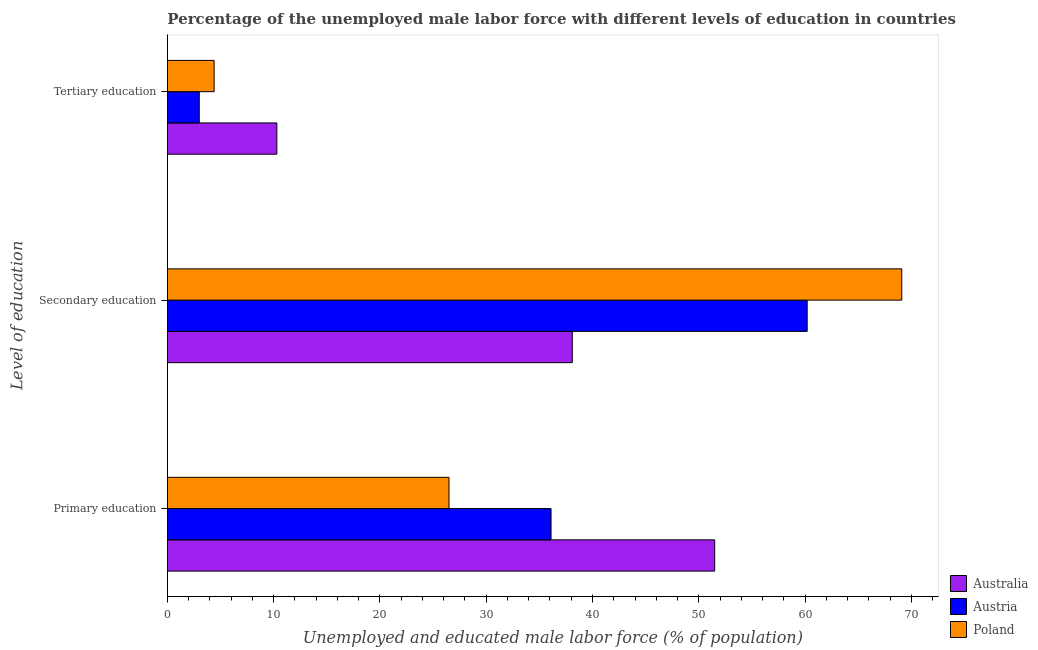How many groups of bars are there?
Provide a succinct answer. 3. Are the number of bars per tick equal to the number of legend labels?
Your answer should be very brief. Yes. How many bars are there on the 3rd tick from the top?
Provide a short and direct response. 3. How many bars are there on the 1st tick from the bottom?
Your response must be concise. 3. What is the label of the 1st group of bars from the top?
Offer a very short reply. Tertiary education. Across all countries, what is the maximum percentage of male labor force who received tertiary education?
Provide a short and direct response. 10.3. Across all countries, what is the minimum percentage of male labor force who received tertiary education?
Provide a succinct answer. 3. What is the total percentage of male labor force who received primary education in the graph?
Your response must be concise. 114.1. What is the difference between the percentage of male labor force who received secondary education in Australia and that in Poland?
Offer a very short reply. -31. What is the difference between the percentage of male labor force who received secondary education in Austria and the percentage of male labor force who received primary education in Poland?
Your answer should be very brief. 33.7. What is the average percentage of male labor force who received secondary education per country?
Your response must be concise. 55.8. What is the difference between the percentage of male labor force who received primary education and percentage of male labor force who received secondary education in Poland?
Give a very brief answer. -42.6. In how many countries, is the percentage of male labor force who received tertiary education greater than 66 %?
Offer a very short reply. 0. What is the ratio of the percentage of male labor force who received tertiary education in Austria to that in Australia?
Give a very brief answer. 0.29. Is the percentage of male labor force who received primary education in Australia less than that in Poland?
Your answer should be very brief. No. Is the difference between the percentage of male labor force who received primary education in Australia and Poland greater than the difference between the percentage of male labor force who received tertiary education in Australia and Poland?
Make the answer very short. Yes. What is the difference between the highest and the second highest percentage of male labor force who received secondary education?
Give a very brief answer. 8.9. What is the difference between the highest and the lowest percentage of male labor force who received secondary education?
Ensure brevity in your answer.  31. What does the 3rd bar from the top in Secondary education represents?
Make the answer very short. Australia. Is it the case that in every country, the sum of the percentage of male labor force who received primary education and percentage of male labor force who received secondary education is greater than the percentage of male labor force who received tertiary education?
Give a very brief answer. Yes. Are all the bars in the graph horizontal?
Make the answer very short. Yes. How many countries are there in the graph?
Your answer should be compact. 3. What is the difference between two consecutive major ticks on the X-axis?
Make the answer very short. 10. Are the values on the major ticks of X-axis written in scientific E-notation?
Offer a very short reply. No. How are the legend labels stacked?
Offer a very short reply. Vertical. What is the title of the graph?
Provide a succinct answer. Percentage of the unemployed male labor force with different levels of education in countries. What is the label or title of the X-axis?
Your answer should be compact. Unemployed and educated male labor force (% of population). What is the label or title of the Y-axis?
Offer a terse response. Level of education. What is the Unemployed and educated male labor force (% of population) of Australia in Primary education?
Offer a terse response. 51.5. What is the Unemployed and educated male labor force (% of population) of Austria in Primary education?
Your response must be concise. 36.1. What is the Unemployed and educated male labor force (% of population) in Poland in Primary education?
Make the answer very short. 26.5. What is the Unemployed and educated male labor force (% of population) in Australia in Secondary education?
Your response must be concise. 38.1. What is the Unemployed and educated male labor force (% of population) in Austria in Secondary education?
Make the answer very short. 60.2. What is the Unemployed and educated male labor force (% of population) of Poland in Secondary education?
Your response must be concise. 69.1. What is the Unemployed and educated male labor force (% of population) in Australia in Tertiary education?
Give a very brief answer. 10.3. What is the Unemployed and educated male labor force (% of population) of Austria in Tertiary education?
Your response must be concise. 3. What is the Unemployed and educated male labor force (% of population) in Poland in Tertiary education?
Provide a succinct answer. 4.4. Across all Level of education, what is the maximum Unemployed and educated male labor force (% of population) in Australia?
Give a very brief answer. 51.5. Across all Level of education, what is the maximum Unemployed and educated male labor force (% of population) in Austria?
Your answer should be compact. 60.2. Across all Level of education, what is the maximum Unemployed and educated male labor force (% of population) in Poland?
Offer a terse response. 69.1. Across all Level of education, what is the minimum Unemployed and educated male labor force (% of population) of Australia?
Give a very brief answer. 10.3. Across all Level of education, what is the minimum Unemployed and educated male labor force (% of population) of Poland?
Give a very brief answer. 4.4. What is the total Unemployed and educated male labor force (% of population) of Australia in the graph?
Provide a succinct answer. 99.9. What is the total Unemployed and educated male labor force (% of population) of Austria in the graph?
Give a very brief answer. 99.3. What is the difference between the Unemployed and educated male labor force (% of population) in Australia in Primary education and that in Secondary education?
Make the answer very short. 13.4. What is the difference between the Unemployed and educated male labor force (% of population) of Austria in Primary education and that in Secondary education?
Your answer should be very brief. -24.1. What is the difference between the Unemployed and educated male labor force (% of population) in Poland in Primary education and that in Secondary education?
Provide a succinct answer. -42.6. What is the difference between the Unemployed and educated male labor force (% of population) of Australia in Primary education and that in Tertiary education?
Offer a very short reply. 41.2. What is the difference between the Unemployed and educated male labor force (% of population) in Austria in Primary education and that in Tertiary education?
Keep it short and to the point. 33.1. What is the difference between the Unemployed and educated male labor force (% of population) in Poland in Primary education and that in Tertiary education?
Offer a very short reply. 22.1. What is the difference between the Unemployed and educated male labor force (% of population) of Australia in Secondary education and that in Tertiary education?
Provide a short and direct response. 27.8. What is the difference between the Unemployed and educated male labor force (% of population) of Austria in Secondary education and that in Tertiary education?
Provide a succinct answer. 57.2. What is the difference between the Unemployed and educated male labor force (% of population) of Poland in Secondary education and that in Tertiary education?
Provide a succinct answer. 64.7. What is the difference between the Unemployed and educated male labor force (% of population) of Australia in Primary education and the Unemployed and educated male labor force (% of population) of Austria in Secondary education?
Provide a short and direct response. -8.7. What is the difference between the Unemployed and educated male labor force (% of population) of Australia in Primary education and the Unemployed and educated male labor force (% of population) of Poland in Secondary education?
Keep it short and to the point. -17.6. What is the difference between the Unemployed and educated male labor force (% of population) of Austria in Primary education and the Unemployed and educated male labor force (% of population) of Poland in Secondary education?
Provide a short and direct response. -33. What is the difference between the Unemployed and educated male labor force (% of population) in Australia in Primary education and the Unemployed and educated male labor force (% of population) in Austria in Tertiary education?
Make the answer very short. 48.5. What is the difference between the Unemployed and educated male labor force (% of population) of Australia in Primary education and the Unemployed and educated male labor force (% of population) of Poland in Tertiary education?
Provide a succinct answer. 47.1. What is the difference between the Unemployed and educated male labor force (% of population) of Austria in Primary education and the Unemployed and educated male labor force (% of population) of Poland in Tertiary education?
Give a very brief answer. 31.7. What is the difference between the Unemployed and educated male labor force (% of population) of Australia in Secondary education and the Unemployed and educated male labor force (% of population) of Austria in Tertiary education?
Your answer should be very brief. 35.1. What is the difference between the Unemployed and educated male labor force (% of population) in Australia in Secondary education and the Unemployed and educated male labor force (% of population) in Poland in Tertiary education?
Ensure brevity in your answer.  33.7. What is the difference between the Unemployed and educated male labor force (% of population) of Austria in Secondary education and the Unemployed and educated male labor force (% of population) of Poland in Tertiary education?
Your answer should be compact. 55.8. What is the average Unemployed and educated male labor force (% of population) of Australia per Level of education?
Your answer should be very brief. 33.3. What is the average Unemployed and educated male labor force (% of population) in Austria per Level of education?
Offer a terse response. 33.1. What is the average Unemployed and educated male labor force (% of population) in Poland per Level of education?
Give a very brief answer. 33.33. What is the difference between the Unemployed and educated male labor force (% of population) in Australia and Unemployed and educated male labor force (% of population) in Poland in Primary education?
Offer a very short reply. 25. What is the difference between the Unemployed and educated male labor force (% of population) in Austria and Unemployed and educated male labor force (% of population) in Poland in Primary education?
Ensure brevity in your answer.  9.6. What is the difference between the Unemployed and educated male labor force (% of population) in Australia and Unemployed and educated male labor force (% of population) in Austria in Secondary education?
Your response must be concise. -22.1. What is the difference between the Unemployed and educated male labor force (% of population) of Australia and Unemployed and educated male labor force (% of population) of Poland in Secondary education?
Provide a succinct answer. -31. What is the ratio of the Unemployed and educated male labor force (% of population) of Australia in Primary education to that in Secondary education?
Ensure brevity in your answer.  1.35. What is the ratio of the Unemployed and educated male labor force (% of population) in Austria in Primary education to that in Secondary education?
Provide a succinct answer. 0.6. What is the ratio of the Unemployed and educated male labor force (% of population) of Poland in Primary education to that in Secondary education?
Provide a succinct answer. 0.38. What is the ratio of the Unemployed and educated male labor force (% of population) of Austria in Primary education to that in Tertiary education?
Provide a short and direct response. 12.03. What is the ratio of the Unemployed and educated male labor force (% of population) of Poland in Primary education to that in Tertiary education?
Your answer should be very brief. 6.02. What is the ratio of the Unemployed and educated male labor force (% of population) of Australia in Secondary education to that in Tertiary education?
Keep it short and to the point. 3.7. What is the ratio of the Unemployed and educated male labor force (% of population) in Austria in Secondary education to that in Tertiary education?
Offer a terse response. 20.07. What is the ratio of the Unemployed and educated male labor force (% of population) in Poland in Secondary education to that in Tertiary education?
Your answer should be very brief. 15.7. What is the difference between the highest and the second highest Unemployed and educated male labor force (% of population) of Austria?
Your answer should be very brief. 24.1. What is the difference between the highest and the second highest Unemployed and educated male labor force (% of population) of Poland?
Your answer should be compact. 42.6. What is the difference between the highest and the lowest Unemployed and educated male labor force (% of population) in Australia?
Offer a very short reply. 41.2. What is the difference between the highest and the lowest Unemployed and educated male labor force (% of population) in Austria?
Your answer should be compact. 57.2. What is the difference between the highest and the lowest Unemployed and educated male labor force (% of population) of Poland?
Your answer should be compact. 64.7. 